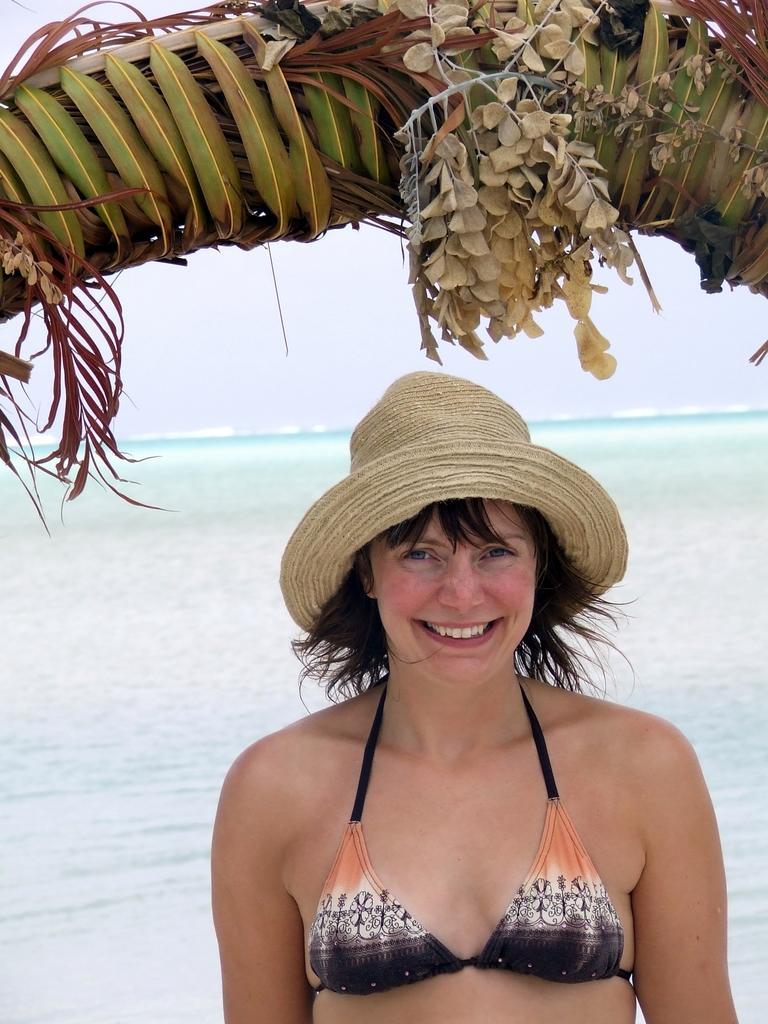Describe this image in one or two sentences. In the image there is a woman standing in front of a beach, she is smiling and she is also wearing a hat, there is a tree branch above her head. 